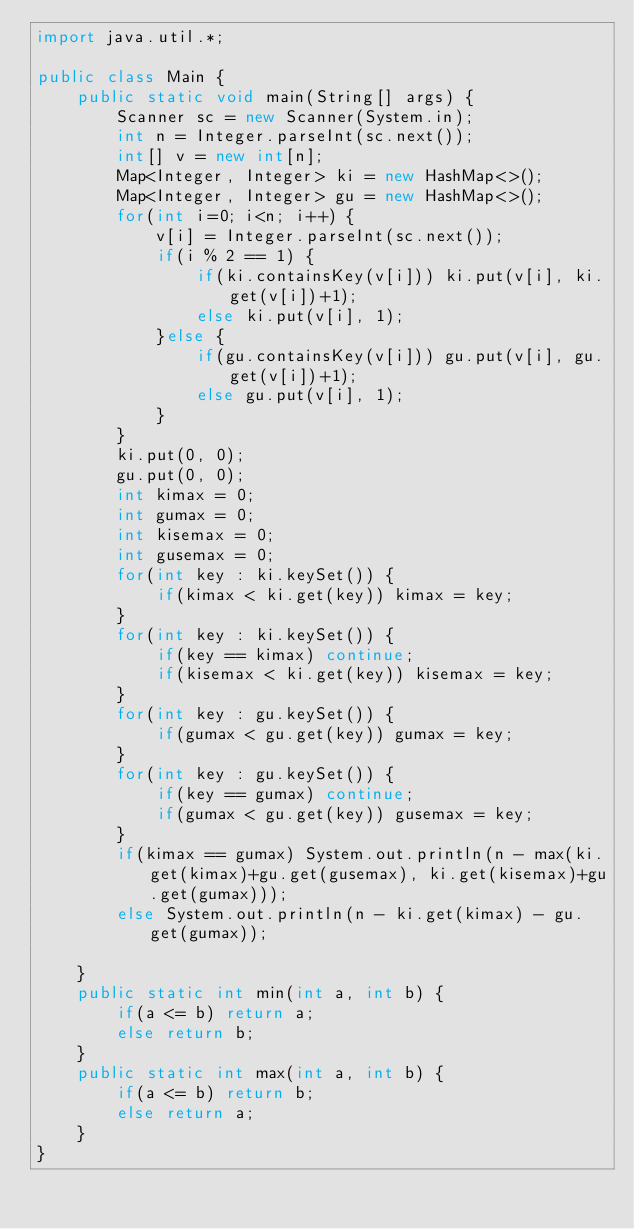Convert code to text. <code><loc_0><loc_0><loc_500><loc_500><_Java_>import java.util.*;
 
public class Main {
    public static void main(String[] args) {
        Scanner sc = new Scanner(System.in);
        int n = Integer.parseInt(sc.next());
        int[] v = new int[n];
        Map<Integer, Integer> ki = new HashMap<>();
        Map<Integer, Integer> gu = new HashMap<>();
        for(int i=0; i<n; i++) {
            v[i] = Integer.parseInt(sc.next());
            if(i % 2 == 1) {
                if(ki.containsKey(v[i])) ki.put(v[i], ki.get(v[i])+1);
                else ki.put(v[i], 1);
            }else {
                if(gu.containsKey(v[i])) gu.put(v[i], gu.get(v[i])+1);
                else gu.put(v[i], 1);
            }
        }
        ki.put(0, 0);
        gu.put(0, 0);
        int kimax = 0;
        int gumax = 0;
        int kisemax = 0;
        int gusemax = 0;
        for(int key : ki.keySet()) {
            if(kimax < ki.get(key)) kimax = key;
        }
        for(int key : ki.keySet()) {
            if(key == kimax) continue;
            if(kisemax < ki.get(key)) kisemax = key;
        }
        for(int key : gu.keySet()) {
            if(gumax < gu.get(key)) gumax = key;
        }
        for(int key : gu.keySet()) {
            if(key == gumax) continue;
            if(gumax < gu.get(key)) gusemax = key;
        }
        if(kimax == gumax) System.out.println(n - max(ki.get(kimax)+gu.get(gusemax), ki.get(kisemax)+gu.get(gumax)));
        else System.out.println(n - ki.get(kimax) - gu.get(gumax));
        
    }
    public static int min(int a, int b) {
        if(a <= b) return a;
        else return b;
    }
    public static int max(int a, int b) {
        if(a <= b) return b;
        else return a;
    }
}</code> 